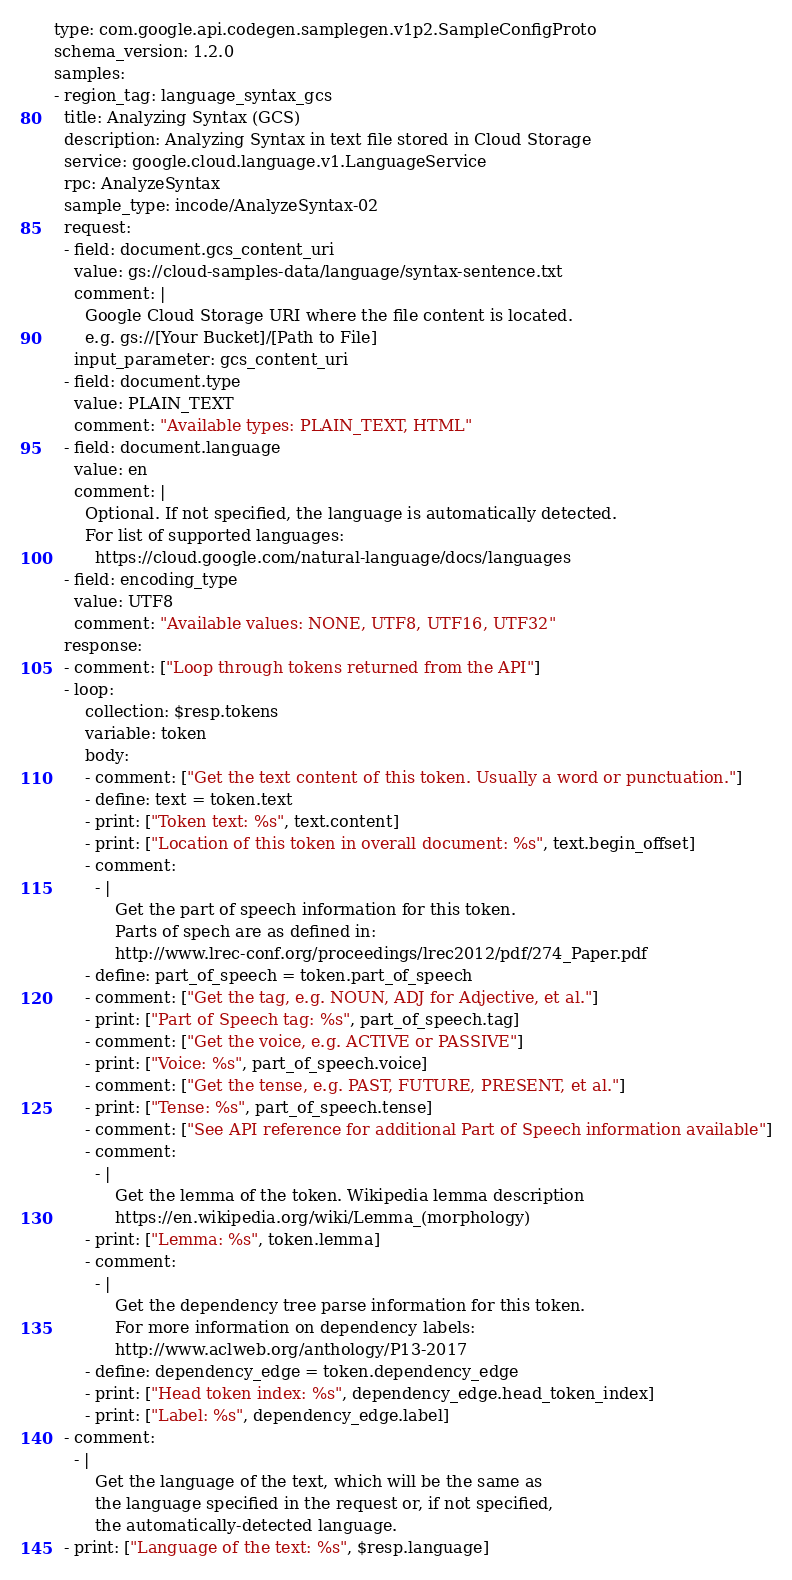Convert code to text. <code><loc_0><loc_0><loc_500><loc_500><_YAML_>type: com.google.api.codegen.samplegen.v1p2.SampleConfigProto
schema_version: 1.2.0
samples:
- region_tag: language_syntax_gcs
  title: Analyzing Syntax (GCS)
  description: Analyzing Syntax in text file stored in Cloud Storage
  service: google.cloud.language.v1.LanguageService
  rpc: AnalyzeSyntax
  sample_type: incode/AnalyzeSyntax-02
  request:
  - field: document.gcs_content_uri
    value: gs://cloud-samples-data/language/syntax-sentence.txt
    comment: |
      Google Cloud Storage URI where the file content is located.
      e.g. gs://[Your Bucket]/[Path to File]
    input_parameter: gcs_content_uri
  - field: document.type
    value: PLAIN_TEXT
    comment: "Available types: PLAIN_TEXT, HTML"
  - field: document.language
    value: en
    comment: |
      Optional. If not specified, the language is automatically detected.
      For list of supported languages:
        https://cloud.google.com/natural-language/docs/languages
  - field: encoding_type
    value: UTF8
    comment: "Available values: NONE, UTF8, UTF16, UTF32"
  response:
  - comment: ["Loop through tokens returned from the API"]
  - loop:
      collection: $resp.tokens
      variable: token
      body:
      - comment: ["Get the text content of this token. Usually a word or punctuation."]
      - define: text = token.text
      - print: ["Token text: %s", text.content]
      - print: ["Location of this token in overall document: %s", text.begin_offset]
      - comment:
        - |
            Get the part of speech information for this token.
            Parts of spech are as defined in:
            http://www.lrec-conf.org/proceedings/lrec2012/pdf/274_Paper.pdf
      - define: part_of_speech = token.part_of_speech
      - comment: ["Get the tag, e.g. NOUN, ADJ for Adjective, et al."]
      - print: ["Part of Speech tag: %s", part_of_speech.tag]
      - comment: ["Get the voice, e.g. ACTIVE or PASSIVE"]
      - print: ["Voice: %s", part_of_speech.voice]
      - comment: ["Get the tense, e.g. PAST, FUTURE, PRESENT, et al."]
      - print: ["Tense: %s", part_of_speech.tense]
      - comment: ["See API reference for additional Part of Speech information available"]
      - comment:
        - |
            Get the lemma of the token. Wikipedia lemma description
            https://en.wikipedia.org/wiki/Lemma_(morphology)
      - print: ["Lemma: %s", token.lemma]
      - comment:
        - |
            Get the dependency tree parse information for this token.
            For more information on dependency labels:
            http://www.aclweb.org/anthology/P13-2017
      - define: dependency_edge = token.dependency_edge
      - print: ["Head token index: %s", dependency_edge.head_token_index]
      - print: ["Label: %s", dependency_edge.label]
  - comment:
    - |
        Get the language of the text, which will be the same as
        the language specified in the request or, if not specified,
        the automatically-detected language.
  - print: ["Language of the text: %s", $resp.language]
</code> 